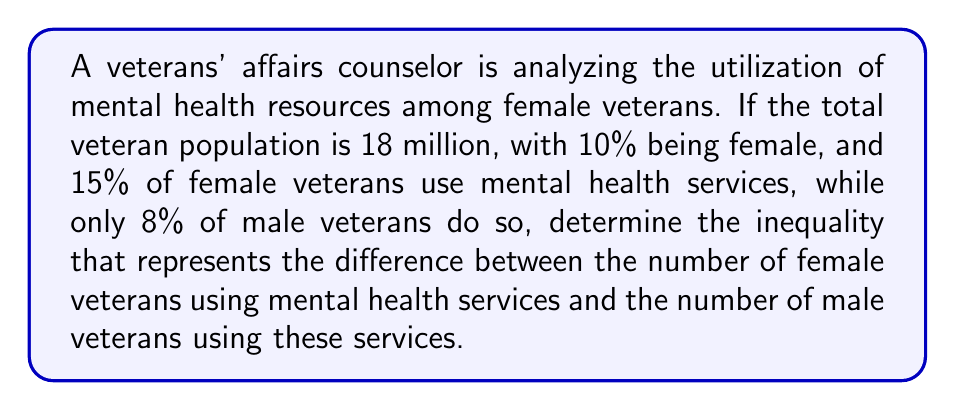Help me with this question. Let's break this down step-by-step:

1) First, calculate the number of female and male veterans:
   Female veterans: $0.10 \times 18,000,000 = 1,800,000$
   Male veterans: $0.90 \times 18,000,000 = 16,200,000$

2) Now, calculate the number of female veterans using mental health services:
   $0.15 \times 1,800,000 = 270,000$

3) Calculate the number of male veterans using mental health services:
   $0.08 \times 16,200,000 = 1,296,000$

4) The question asks for the inequality representing the difference between female and male veterans using services:
   $270,000 < 1,296,000$

5) To express this as a proper inequality:
   $$\text{Number of female veterans using services} < \text{Number of male veterans using services}$$

6) Or mathematically:
   $$0.15(0.10 \times 18,000,000) < 0.08(0.90 \times 18,000,000)$$
Answer: $0.15(0.10 \times 18,000,000) < 0.08(0.90 \times 18,000,000)$ 